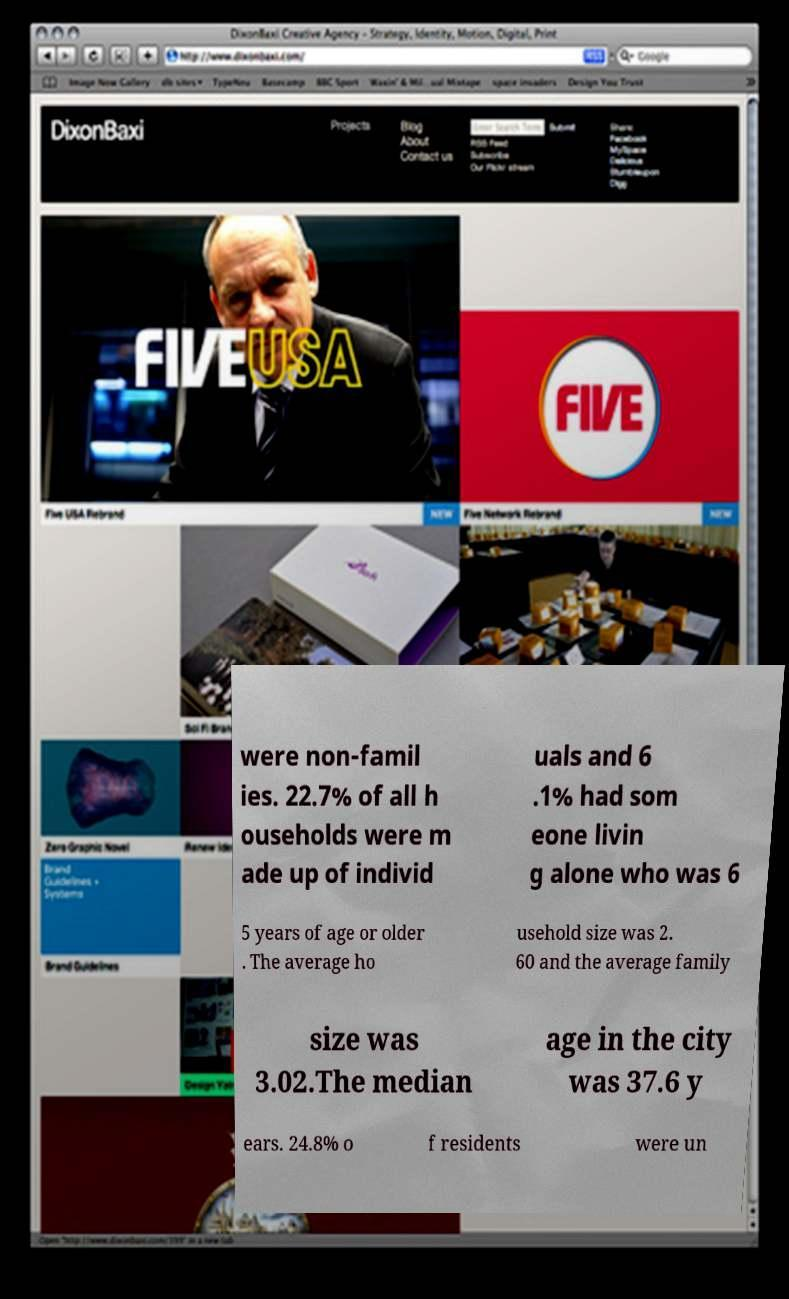For documentation purposes, I need the text within this image transcribed. Could you provide that? were non-famil ies. 22.7% of all h ouseholds were m ade up of individ uals and 6 .1% had som eone livin g alone who was 6 5 years of age or older . The average ho usehold size was 2. 60 and the average family size was 3.02.The median age in the city was 37.6 y ears. 24.8% o f residents were un 